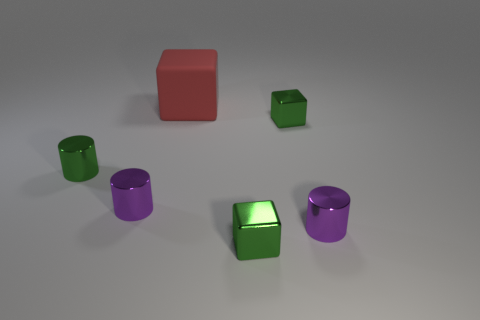There is a rubber cube; is it the same size as the cylinder on the right side of the red object?
Your answer should be very brief. No. Are there an equal number of red cubes left of the tiny green shiny cylinder and things to the right of the matte thing?
Offer a terse response. No. There is a small purple metal cylinder that is on the left side of the tiny thing behind the green cylinder; what number of small purple cylinders are on the left side of it?
Your answer should be very brief. 0. There is a red matte block behind the green cylinder; what is its size?
Your answer should be compact. Large. There is a green object behind the green metallic cylinder; is its shape the same as the big red rubber thing?
Provide a short and direct response. Yes. Is there anything else that is the same size as the red object?
Offer a terse response. No. Are there any large brown metallic things?
Ensure brevity in your answer.  No. What is the material of the red thing that is behind the purple metal thing that is to the left of the tiny purple object that is right of the red object?
Provide a succinct answer. Rubber. Is the shape of the large thing the same as the green shiny thing in front of the green metallic cylinder?
Your answer should be very brief. Yes. How many tiny green shiny objects have the same shape as the big rubber thing?
Offer a very short reply. 2. 